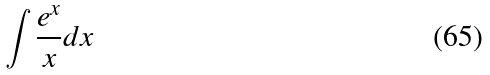<formula> <loc_0><loc_0><loc_500><loc_500>\int \frac { e ^ { x } } { x } d x</formula> 